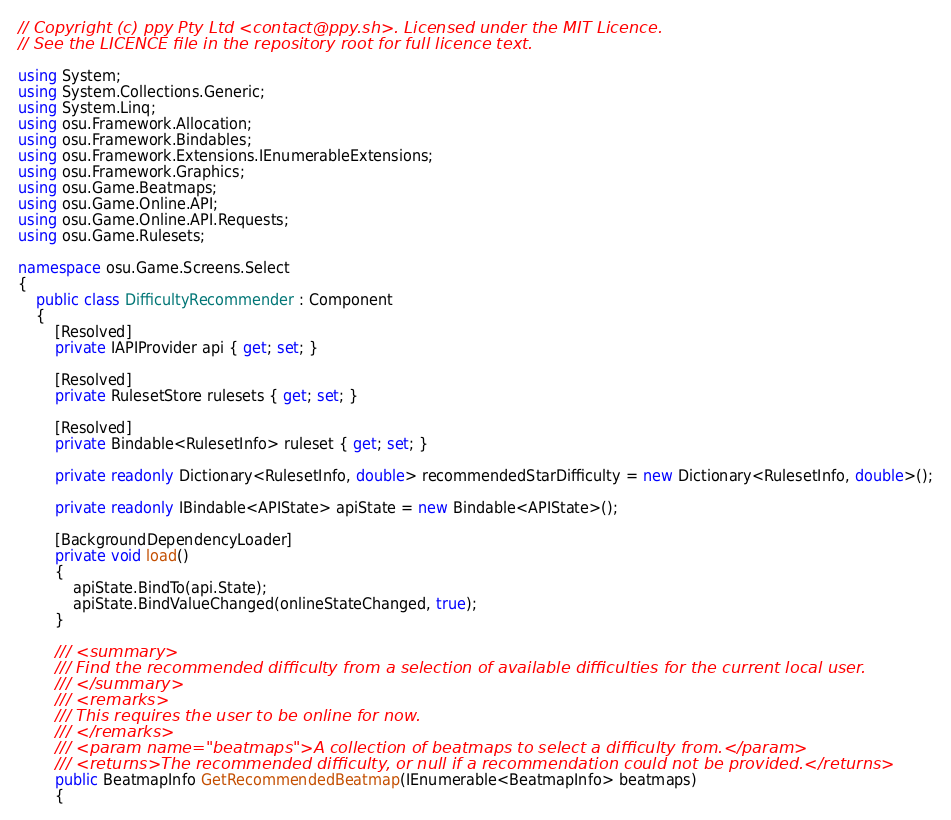Convert code to text. <code><loc_0><loc_0><loc_500><loc_500><_C#_>// Copyright (c) ppy Pty Ltd <contact@ppy.sh>. Licensed under the MIT Licence.
// See the LICENCE file in the repository root for full licence text.

using System;
using System.Collections.Generic;
using System.Linq;
using osu.Framework.Allocation;
using osu.Framework.Bindables;
using osu.Framework.Extensions.IEnumerableExtensions;
using osu.Framework.Graphics;
using osu.Game.Beatmaps;
using osu.Game.Online.API;
using osu.Game.Online.API.Requests;
using osu.Game.Rulesets;

namespace osu.Game.Screens.Select
{
    public class DifficultyRecommender : Component
    {
        [Resolved]
        private IAPIProvider api { get; set; }

        [Resolved]
        private RulesetStore rulesets { get; set; }

        [Resolved]
        private Bindable<RulesetInfo> ruleset { get; set; }

        private readonly Dictionary<RulesetInfo, double> recommendedStarDifficulty = new Dictionary<RulesetInfo, double>();

        private readonly IBindable<APIState> apiState = new Bindable<APIState>();

        [BackgroundDependencyLoader]
        private void load()
        {
            apiState.BindTo(api.State);
            apiState.BindValueChanged(onlineStateChanged, true);
        }

        /// <summary>
        /// Find the recommended difficulty from a selection of available difficulties for the current local user.
        /// </summary>
        /// <remarks>
        /// This requires the user to be online for now.
        /// </remarks>
        /// <param name="beatmaps">A collection of beatmaps to select a difficulty from.</param>
        /// <returns>The recommended difficulty, or null if a recommendation could not be provided.</returns>
        public BeatmapInfo GetRecommendedBeatmap(IEnumerable<BeatmapInfo> beatmaps)
        {</code> 